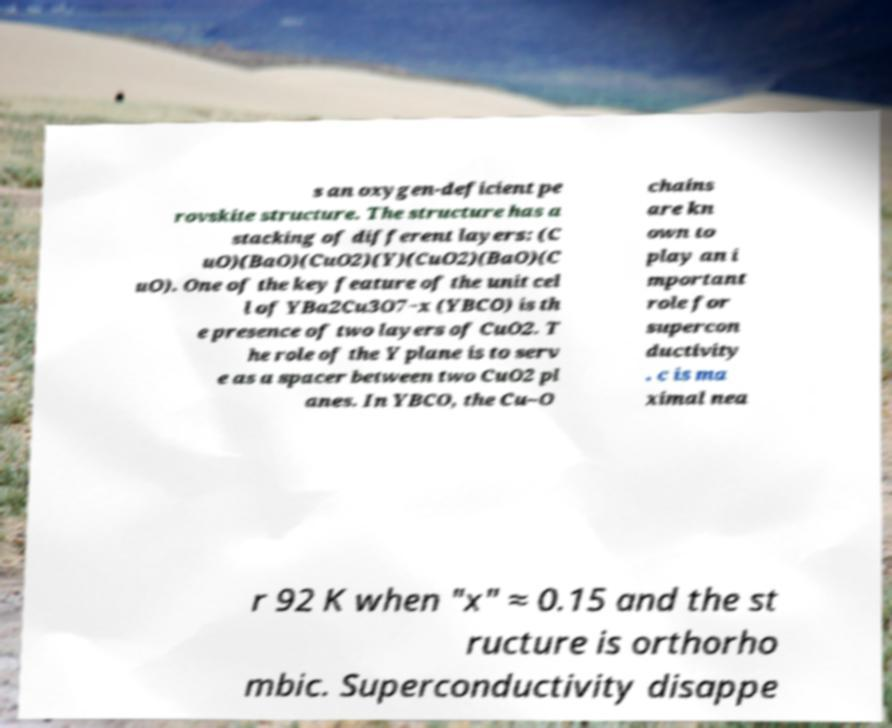Please identify and transcribe the text found in this image. s an oxygen-deficient pe rovskite structure. The structure has a stacking of different layers: (C uO)(BaO)(CuO2)(Y)(CuO2)(BaO)(C uO). One of the key feature of the unit cel l of YBa2Cu3O7−x (YBCO) is th e presence of two layers of CuO2. T he role of the Y plane is to serv e as a spacer between two CuO2 pl anes. In YBCO, the Cu–O chains are kn own to play an i mportant role for supercon ductivity . c is ma ximal nea r 92 K when "x" ≈ 0.15 and the st ructure is orthorho mbic. Superconductivity disappe 